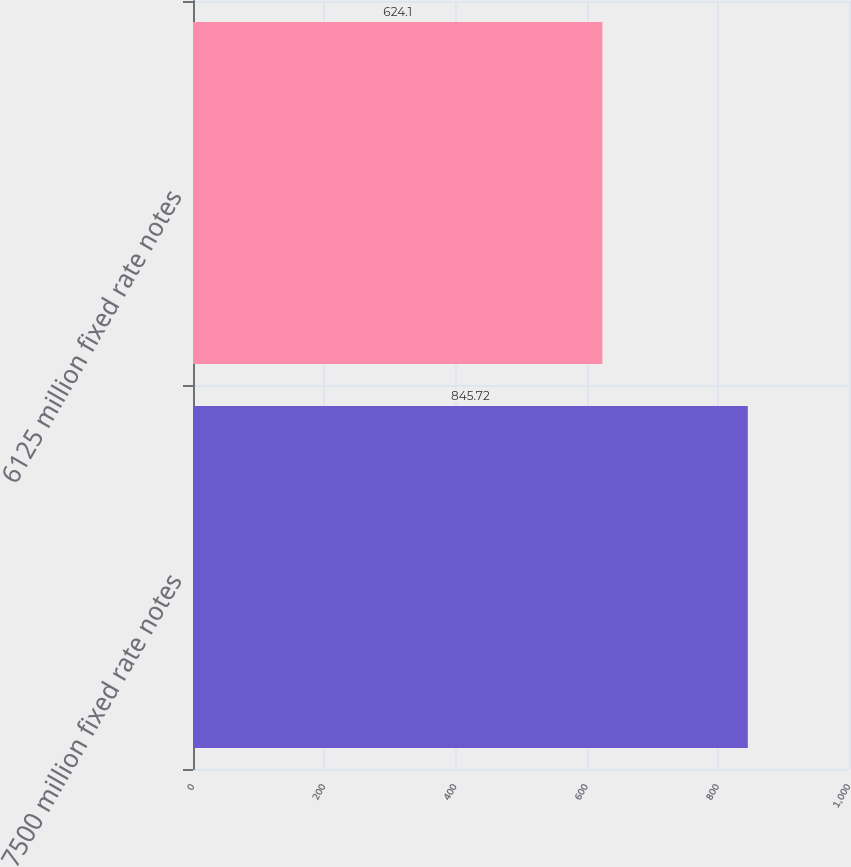Convert chart. <chart><loc_0><loc_0><loc_500><loc_500><bar_chart><fcel>7500 million fixed rate notes<fcel>6125 million fixed rate notes<nl><fcel>845.72<fcel>624.1<nl></chart> 